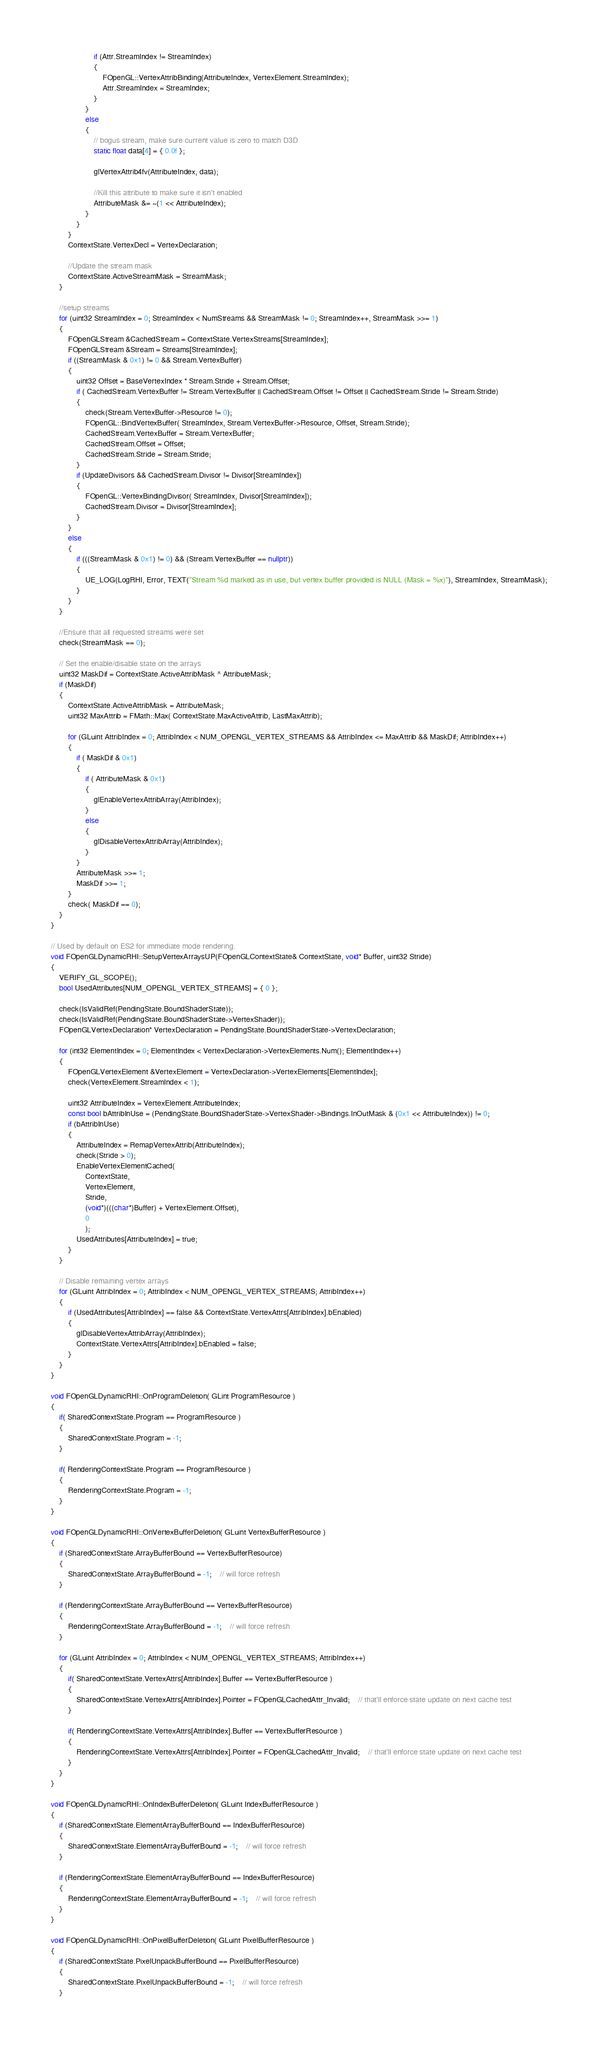Convert code to text. <code><loc_0><loc_0><loc_500><loc_500><_C++_>					if (Attr.StreamIndex != StreamIndex)
					{
						FOpenGL::VertexAttribBinding(AttributeIndex, VertexElement.StreamIndex);
						Attr.StreamIndex = StreamIndex;
					}
				}
				else
				{
					// bogus stream, make sure current value is zero to match D3D
					static float data[4] = { 0.0f };

					glVertexAttrib4fv(AttributeIndex, data);

					//Kill this attribute to make sure it isn't enabled
					AttributeMask &= ~(1 << AttributeIndex);
				}
			}
		}
		ContextState.VertexDecl = VertexDeclaration;

		//Update the stream mask
		ContextState.ActiveStreamMask = StreamMask;
	}

	//setup streams
	for (uint32 StreamIndex = 0; StreamIndex < NumStreams && StreamMask != 0; StreamIndex++, StreamMask >>= 1)
	{
		FOpenGLStream &CachedStream = ContextState.VertexStreams[StreamIndex];
		FOpenGLStream &Stream = Streams[StreamIndex];
		if ((StreamMask & 0x1) != 0 && Stream.VertexBuffer)
		{
			uint32 Offset = BaseVertexIndex * Stream.Stride + Stream.Offset;
			if ( CachedStream.VertexBuffer != Stream.VertexBuffer || CachedStream.Offset != Offset || CachedStream.Stride != Stream.Stride)
			{
				check(Stream.VertexBuffer->Resource != 0);
				FOpenGL::BindVertexBuffer( StreamIndex, Stream.VertexBuffer->Resource, Offset, Stream.Stride);
				CachedStream.VertexBuffer = Stream.VertexBuffer;
				CachedStream.Offset = Offset;
				CachedStream.Stride = Stream.Stride;
			}
			if (UpdateDivisors && CachedStream.Divisor != Divisor[StreamIndex])
			{
				FOpenGL::VertexBindingDivisor( StreamIndex, Divisor[StreamIndex]);
				CachedStream.Divisor = Divisor[StreamIndex];
			}
		}
		else
		{
			if (((StreamMask & 0x1) != 0) && (Stream.VertexBuffer == nullptr))
			{
				UE_LOG(LogRHI, Error, TEXT("Stream %d marked as in use, but vertex buffer provided is NULL (Mask = %x)"), StreamIndex, StreamMask);
			}
		}
	}

	//Ensure that all requested streams were set
	check(StreamMask == 0);

	// Set the enable/disable state on the arrays
	uint32 MaskDif = ContextState.ActiveAttribMask ^ AttributeMask;
	if (MaskDif)
	{
		ContextState.ActiveAttribMask = AttributeMask;
		uint32 MaxAttrib = FMath::Max( ContextState.MaxActiveAttrib, LastMaxAttrib);
	
		for (GLuint AttribIndex = 0; AttribIndex < NUM_OPENGL_VERTEX_STREAMS && AttribIndex <= MaxAttrib && MaskDif; AttribIndex++)
		{
			if ( MaskDif & 0x1)
			{
				if ( AttributeMask & 0x1)
				{
					glEnableVertexAttribArray(AttribIndex);
				}
				else
				{
					glDisableVertexAttribArray(AttribIndex);
				}
			}
			AttributeMask >>= 1;
			MaskDif >>= 1;
		}
		check( MaskDif == 0);
	}
}

// Used by default on ES2 for immediate mode rendering.
void FOpenGLDynamicRHI::SetupVertexArraysUP(FOpenGLContextState& ContextState, void* Buffer, uint32 Stride)
{
	VERIFY_GL_SCOPE();
	bool UsedAttributes[NUM_OPENGL_VERTEX_STREAMS] = { 0 };

	check(IsValidRef(PendingState.BoundShaderState));
	check(IsValidRef(PendingState.BoundShaderState->VertexShader));
	FOpenGLVertexDeclaration* VertexDeclaration = PendingState.BoundShaderState->VertexDeclaration;

	for (int32 ElementIndex = 0; ElementIndex < VertexDeclaration->VertexElements.Num(); ElementIndex++)
	{
		FOpenGLVertexElement &VertexElement = VertexDeclaration->VertexElements[ElementIndex];
		check(VertexElement.StreamIndex < 1);

		uint32 AttributeIndex = VertexElement.AttributeIndex;
		const bool bAttribInUse = (PendingState.BoundShaderState->VertexShader->Bindings.InOutMask & (0x1 << AttributeIndex)) != 0;
		if (bAttribInUse)
		{
			AttributeIndex = RemapVertexAttrib(AttributeIndex);
			check(Stride > 0);
			EnableVertexElementCached(
				ContextState,
				VertexElement,
				Stride,
				(void*)(((char*)Buffer) + VertexElement.Offset),
				0
				);
			UsedAttributes[AttributeIndex] = true;
		}
	}

	// Disable remaining vertex arrays
	for (GLuint AttribIndex = 0; AttribIndex < NUM_OPENGL_VERTEX_STREAMS; AttribIndex++)
	{
		if (UsedAttributes[AttribIndex] == false && ContextState.VertexAttrs[AttribIndex].bEnabled)
		{
			glDisableVertexAttribArray(AttribIndex);
			ContextState.VertexAttrs[AttribIndex].bEnabled = false;
		}
	}
}

void FOpenGLDynamicRHI::OnProgramDeletion( GLint ProgramResource )
{
	if( SharedContextState.Program == ProgramResource )
	{
		SharedContextState.Program = -1;
	}

	if( RenderingContextState.Program == ProgramResource )
	{
		RenderingContextState.Program = -1;
	}
}

void FOpenGLDynamicRHI::OnVertexBufferDeletion( GLuint VertexBufferResource )
{
	if (SharedContextState.ArrayBufferBound == VertexBufferResource)
	{
		SharedContextState.ArrayBufferBound = -1;	// will force refresh
	}

	if (RenderingContextState.ArrayBufferBound == VertexBufferResource)
	{
		RenderingContextState.ArrayBufferBound = -1;	// will force refresh
	}

	for (GLuint AttribIndex = 0; AttribIndex < NUM_OPENGL_VERTEX_STREAMS; AttribIndex++)
	{
		if( SharedContextState.VertexAttrs[AttribIndex].Buffer == VertexBufferResource )
		{
			SharedContextState.VertexAttrs[AttribIndex].Pointer = FOpenGLCachedAttr_Invalid;	// that'll enforce state update on next cache test
		}

		if( RenderingContextState.VertexAttrs[AttribIndex].Buffer == VertexBufferResource )
		{
			RenderingContextState.VertexAttrs[AttribIndex].Pointer = FOpenGLCachedAttr_Invalid;	// that'll enforce state update on next cache test
		}
	}
}

void FOpenGLDynamicRHI::OnIndexBufferDeletion( GLuint IndexBufferResource )
{
	if (SharedContextState.ElementArrayBufferBound == IndexBufferResource)
	{
		SharedContextState.ElementArrayBufferBound = -1;	// will force refresh
	}

	if (RenderingContextState.ElementArrayBufferBound == IndexBufferResource)
	{
		RenderingContextState.ElementArrayBufferBound = -1;	// will force refresh
	}
}

void FOpenGLDynamicRHI::OnPixelBufferDeletion( GLuint PixelBufferResource )
{
	if (SharedContextState.PixelUnpackBufferBound == PixelBufferResource)
	{
		SharedContextState.PixelUnpackBufferBound = -1;	// will force refresh
	}
</code> 